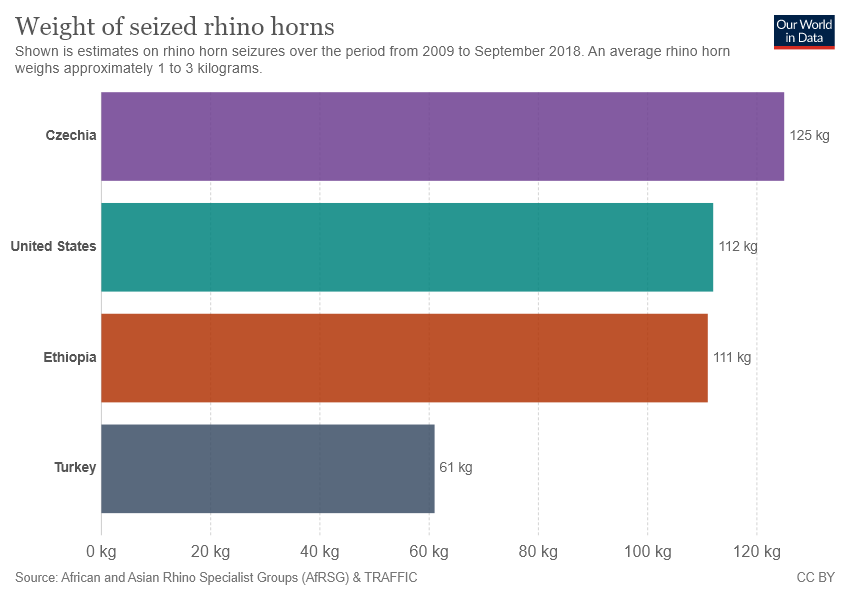Point out several critical features in this image. The weight difference in Rhino horns among countries with the highest and lowest weights is 64. Ethiopia is represented by the color brown. 